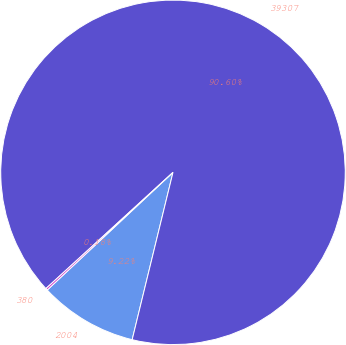Convert chart. <chart><loc_0><loc_0><loc_500><loc_500><pie_chart><fcel>2004<fcel>39307<fcel>380<nl><fcel>9.22%<fcel>90.6%<fcel>0.18%<nl></chart> 